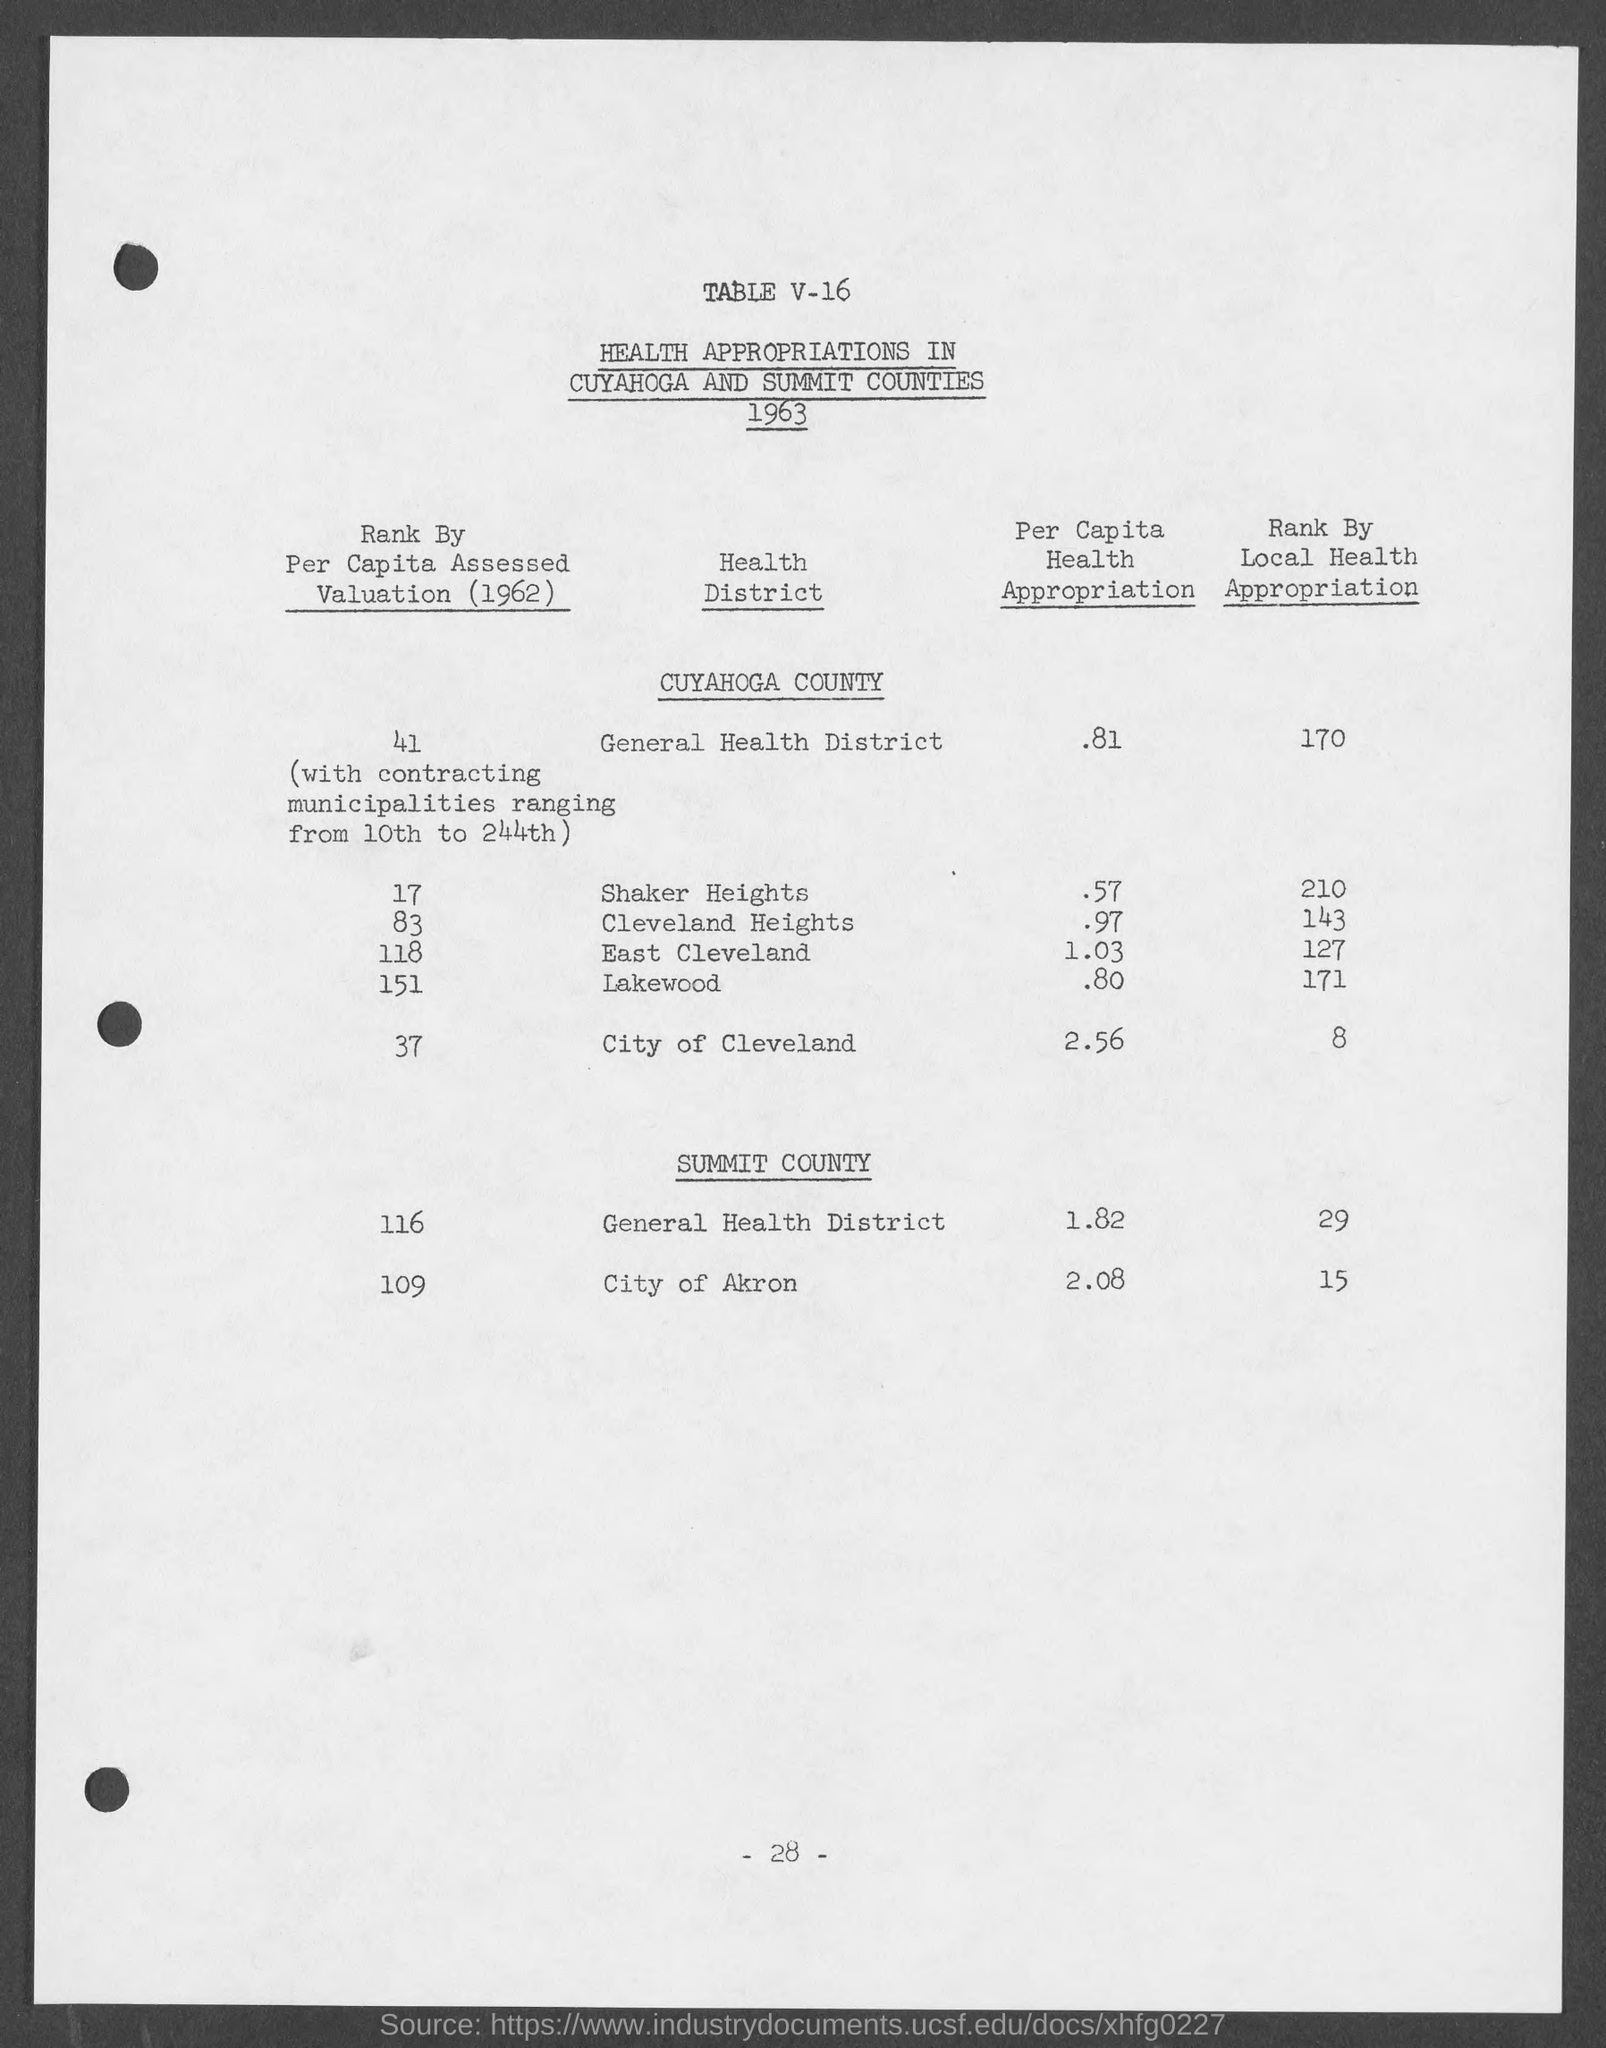What is the Per Capita Health Appropriation for general health district in Cuyahoga County?
Keep it short and to the point. .81. What is the Per Capita Health Appropriation for Shaker Heights?
Your answer should be compact. .57. What is the Per Capita Health Appropriation for Cleveland Heights?
Your answer should be compact. .97. What is the Per Capita Health Appropriation for East Cleveland?
Offer a very short reply. 1.03. What is the Per Capita Health Appropriation for Lakewood?
Your answer should be very brief. .80. What is the Per Capita Health Appropriation for City of Cleveland?
Your response must be concise. 2.56. What is the Per Capita Health Appropriation for City of Akron?
Provide a succinct answer. 2.08. What is the Per Capita Health Appropriation for general health district in Summit County?
Provide a succinct answer. 1.82. What is the Page Number?
Make the answer very short. - 28 -. 